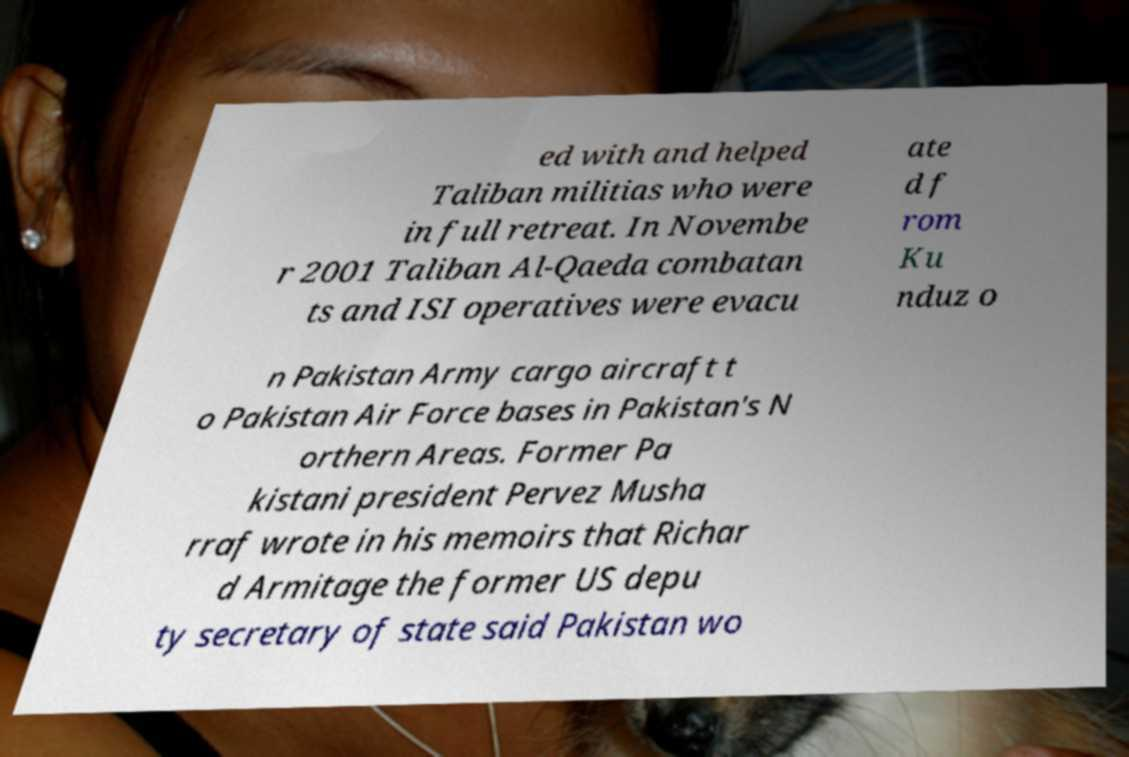Can you read and provide the text displayed in the image?This photo seems to have some interesting text. Can you extract and type it out for me? ed with and helped Taliban militias who were in full retreat. In Novembe r 2001 Taliban Al-Qaeda combatan ts and ISI operatives were evacu ate d f rom Ku nduz o n Pakistan Army cargo aircraft t o Pakistan Air Force bases in Pakistan's N orthern Areas. Former Pa kistani president Pervez Musha rraf wrote in his memoirs that Richar d Armitage the former US depu ty secretary of state said Pakistan wo 